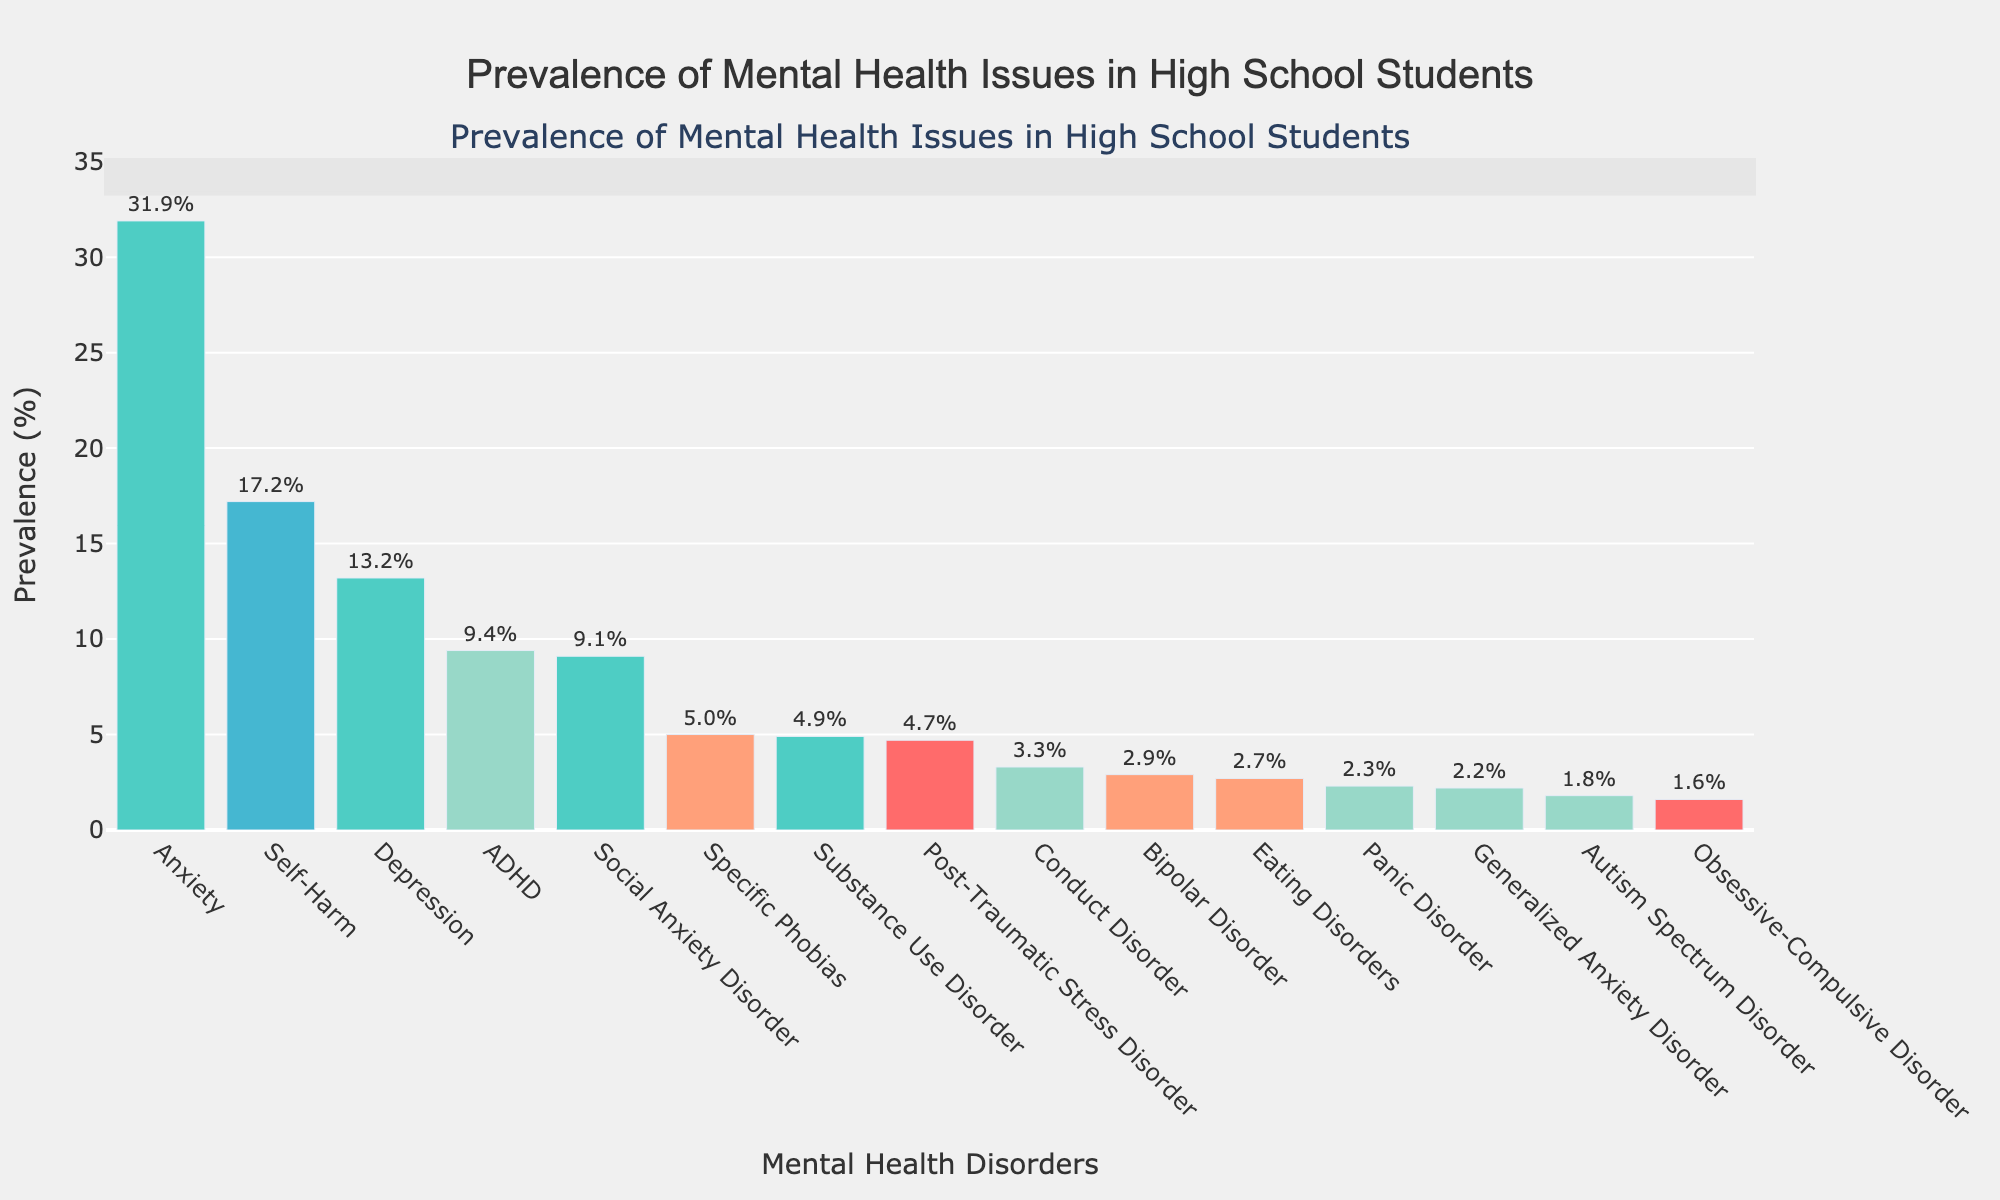Which mental health disorder has the highest prevalence among high school students? The bar chart shows the prevalence of various mental health issues, and the tallest bar represents the disorder with the highest prevalence. Anxiety has the highest prevalence at 31.9%.
Answer: Anxiety What is the difference in prevalence between Anxiety and Depression? Anxiety has a prevalence of 31.9% and Depression has a prevalence of 13.2%. Subtract the prevalence of Depression from Anxiety: 31.9% - 13.2% = 18.7%.
Answer: 18.7% How many disorders have a prevalence less than 5%? By looking at the bars below the 5% mark on the y-axis, we count them. These are Eating Disorders, Bipolar Disorder, Conduct Disorder, Obsessive-Compulsive Disorder (OCD), Post-Traumatic Stress Disorder (PTSD), Autism Spectrum Disorder (ASD), Generalized Anxiety Disorder, Panic Disorder, and Specific Phobias (totally 9).
Answer: 9 Which disorders have a prevalence higher than 10%? Observing the bar chart for bars extending above the 10% mark, we identify Anxiety (31.9%), Depression (13.2%), and Self-Harm (17.2%).
Answer: Anxiety, Depression, Self-Harm Is the prevalence of Substance Use Disorder higher than Conduct Disorder? Comparing the heights of the bars for Substance Use Disorder (4.9%) and Conduct Disorder (3.3%), we see that Substance Use Disorder's bar is taller.
Answer: Yes What's the sum of the prevalence for Social Anxiety Disorder and Panic Disorder? The prevalence of Social Anxiety Disorder is 9.1% and Panic Disorder is 2.3%. Add these two together: 9.1% + 2.3% = 11.4%.
Answer: 11.4% Which disorder has a higher prevalence: Autism Spectrum Disorder or Generalized Anxiety Disorder? Comparing the data labels, Autism Spectrum Disorder has a prevalence of 1.8% and Generalized Anxiety Disorder has a prevalence of 2.2%. Generalized Anxiety Disorder's bar is taller.
Answer: Generalized Anxiety Disorder What's the median prevalence of the listed mental health disorders? To find the median, we list all the prevalence values in descending order: 31.9%, 17.2%, 13.2%, 9.4%, 9.1%, 5.0%, 4.9%, 4.7%, 3.3%, 2.9%, 2.7%, 2.3%, 2.2%, 1.8%, 1.6%. The middle value in this ordered list is ADHD (9.4%).
Answer: 9.4% Which disorder represented by a green bar has the highest prevalence? Reviewing the bar chart, identify the disorder among those labeled green. Out of these, Anxiety has the highest prevalence at 31.9%.
Answer: Anxiety 